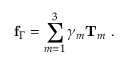Convert formula to latex. <formula><loc_0><loc_0><loc_500><loc_500>f _ { \Gamma } = \sum _ { m = 1 } ^ { 3 } \gamma _ { m } T _ { m } .</formula> 